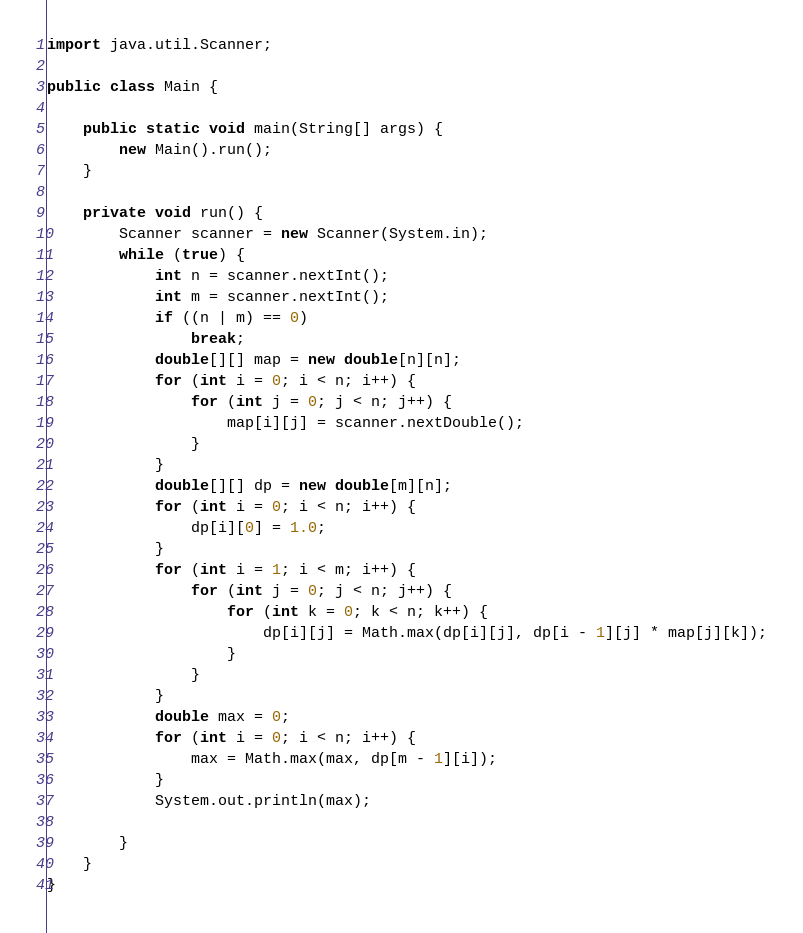Convert code to text. <code><loc_0><loc_0><loc_500><loc_500><_Java_>
import java.util.Scanner;

public class Main {

	public static void main(String[] args) {
		new Main().run();
	}

	private void run() {
		Scanner scanner = new Scanner(System.in);
		while (true) {
			int n = scanner.nextInt();
			int m = scanner.nextInt();
			if ((n | m) == 0)
				break;
			double[][] map = new double[n][n];
			for (int i = 0; i < n; i++) {
				for (int j = 0; j < n; j++) {
					map[i][j] = scanner.nextDouble();
				}
			}
			double[][] dp = new double[m][n];
			for (int i = 0; i < n; i++) {
				dp[i][0] = 1.0;
			}
			for (int i = 1; i < m; i++) {
				for (int j = 0; j < n; j++) {
					for (int k = 0; k < n; k++) {
						dp[i][j] = Math.max(dp[i][j], dp[i - 1][j] * map[j][k]);
					}
				}
			}
			double max = 0;
			for (int i = 0; i < n; i++) {
				max = Math.max(max, dp[m - 1][i]);
			}
			System.out.println(max);

		}
	}
}</code> 